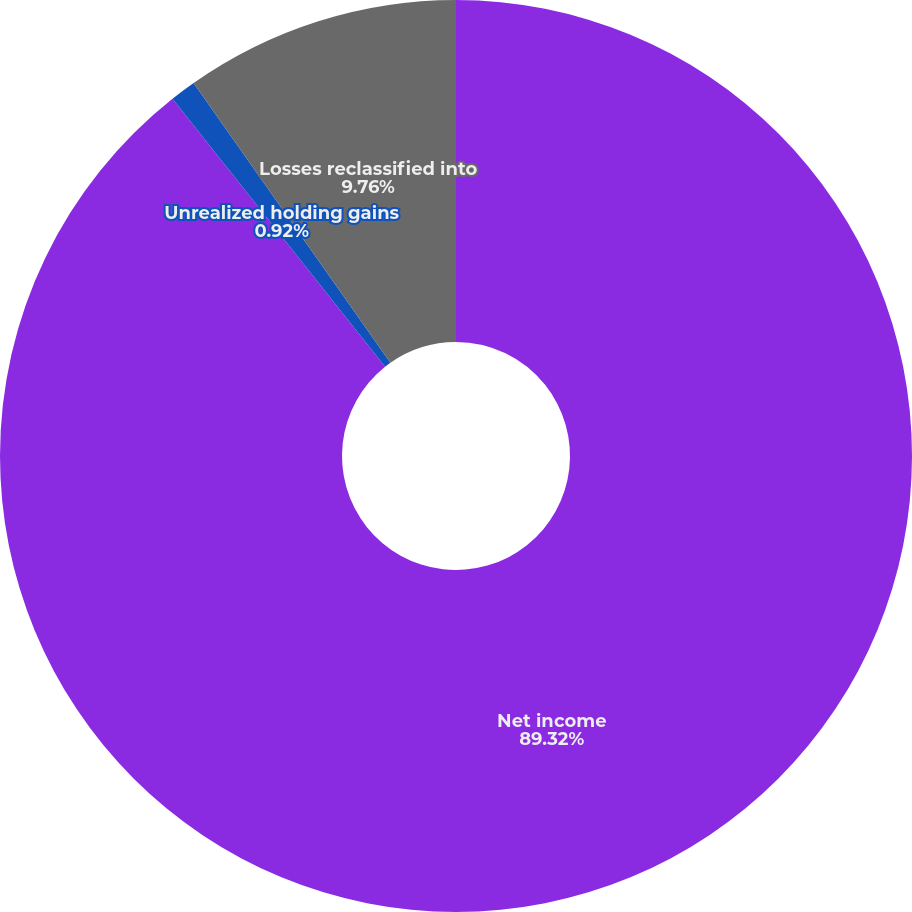<chart> <loc_0><loc_0><loc_500><loc_500><pie_chart><fcel>Net income<fcel>Unrealized holding gains<fcel>Losses reclassified into<nl><fcel>89.33%<fcel>0.92%<fcel>9.76%<nl></chart> 